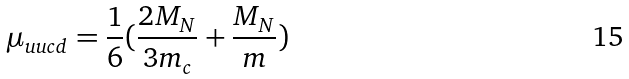Convert formula to latex. <formula><loc_0><loc_0><loc_500><loc_500>\mu _ { u u c d } = \frac { 1 } { 6 } ( \frac { 2 M _ { N } } { 3 m _ { c } } + \frac { M _ { N } } { m } )</formula> 